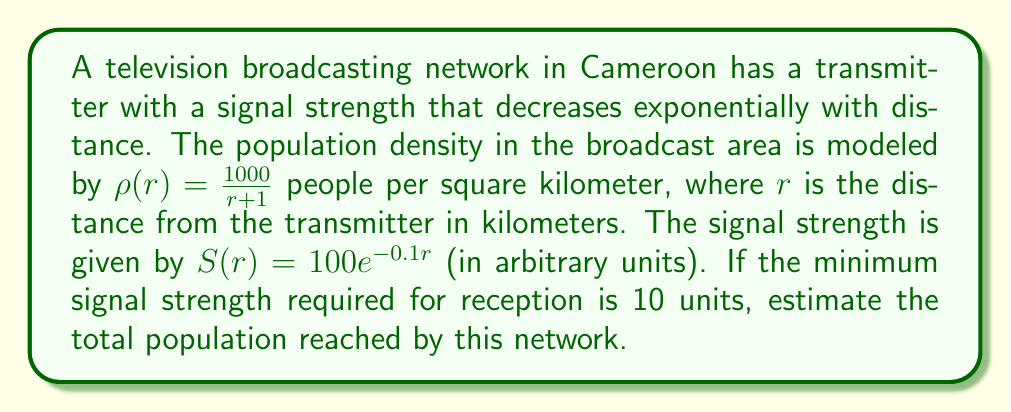Solve this math problem. To solve this problem, we'll follow these steps:

1) First, we need to find the maximum distance $R$ at which the signal can be received. We can do this by setting $S(R) = 10$ and solving for $R$:

   $10 = 100e^{-0.1R}$
   $0.1 = e^{-0.1R}$
   $\ln(0.1) = -0.1R$
   $R = -\frac{\ln(0.1)}{0.1} \approx 23.03$ km

2) Now, we need to integrate the population density function over the circular area covered by the signal. The population $P$ is given by:

   $P = \int_0^R 2\pi r \rho(r) dr = \int_0^R 2\pi r \frac{1000}{r+1} dr$

3) Let's solve this integral:

   $P = 2000\pi \int_0^R \frac{r}{r+1} dr$
   
   $= 2000\pi [r - \ln(r+1)]_0^R$
   
   $= 2000\pi [R - \ln(R+1) - (0 - \ln(1))]$
   
   $= 2000\pi [R - \ln(R+1)]$

4) Substituting $R \approx 23.03$:

   $P \approx 2000\pi [23.03 - \ln(24.03)]$
   
   $\approx 2000\pi [23.03 - 3.18]$
   
   $\approx 2000\pi (19.85)$
   
   $\approx 124,836$ people

5) Rounding to the nearest thousand for a reasonable estimate:

   $P \approx 125,000$ people
Answer: 125,000 people 